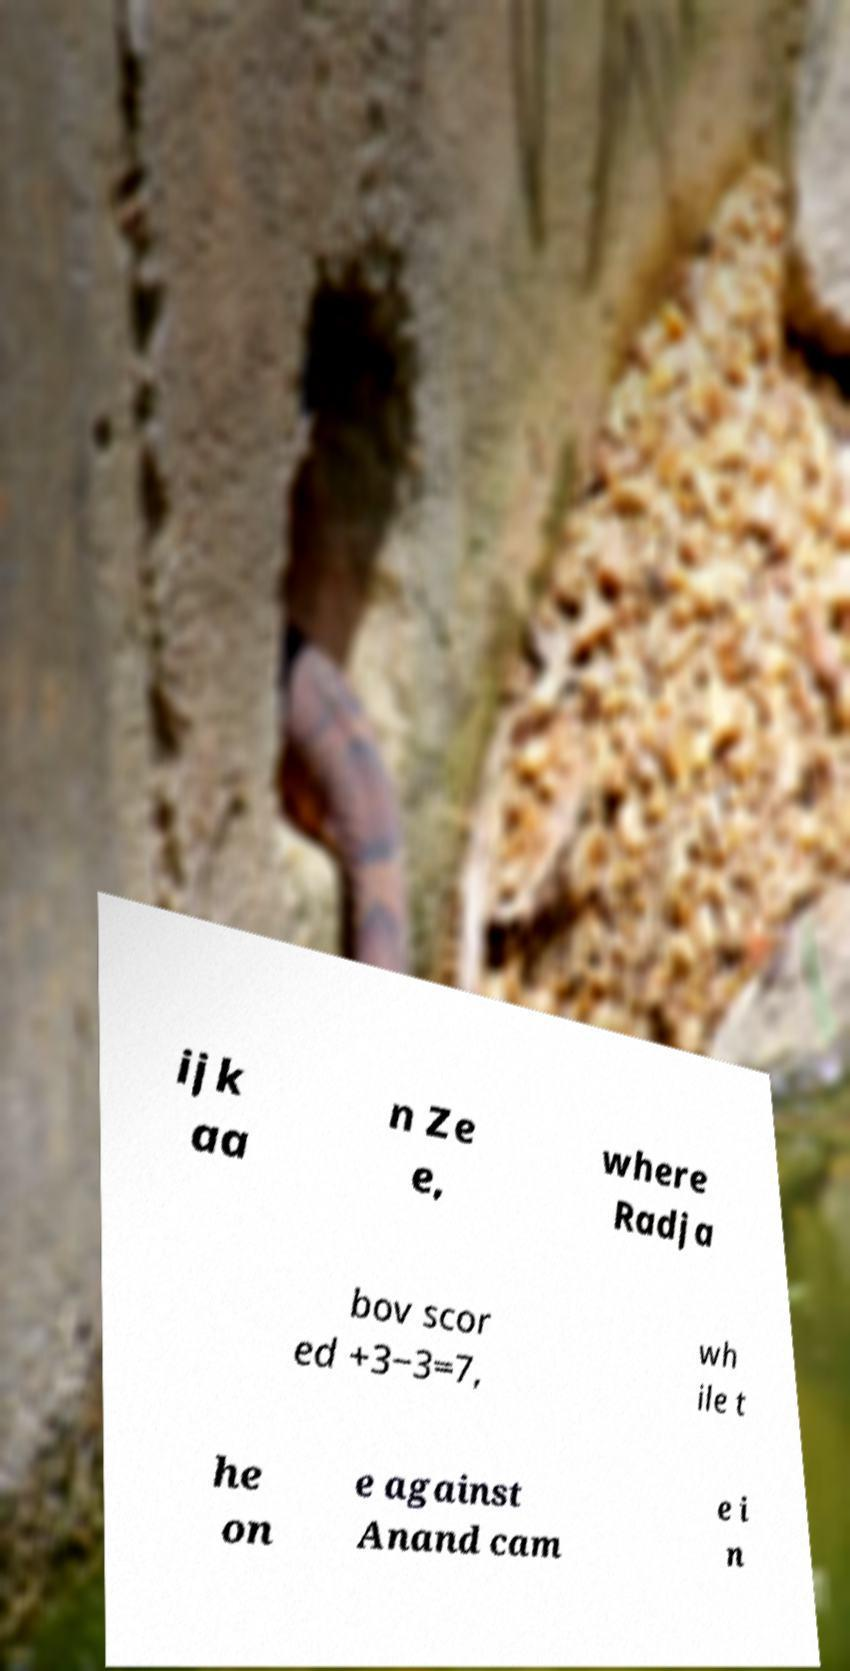Could you assist in decoding the text presented in this image and type it out clearly? ijk aa n Ze e, where Radja bov scor ed +3−3=7, wh ile t he on e against Anand cam e i n 